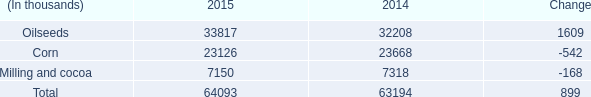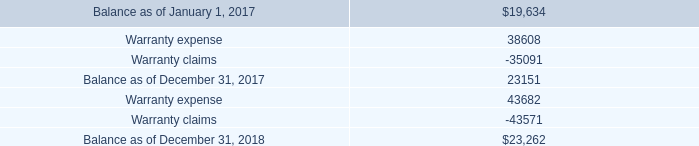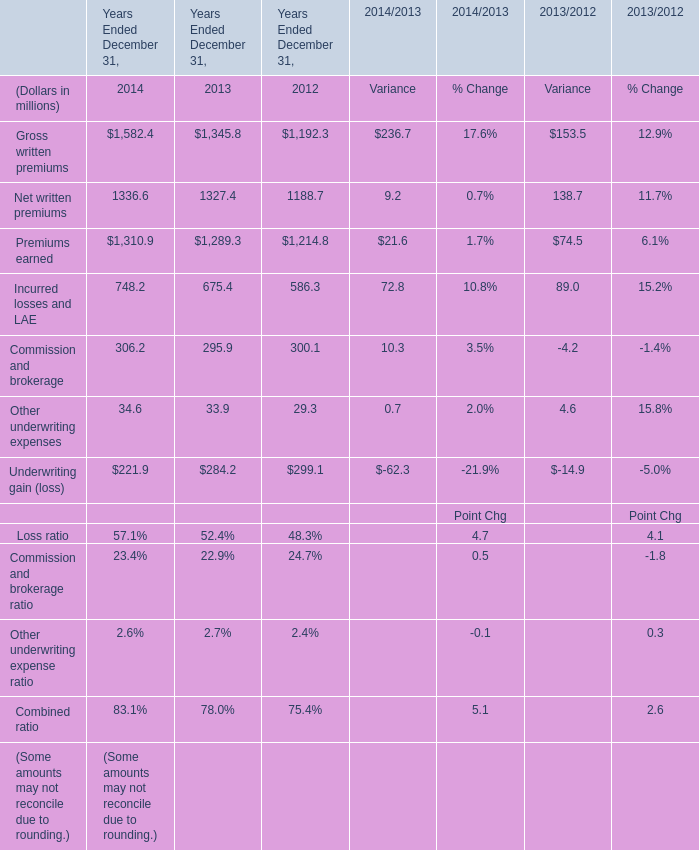What's the sum of Gross written premiums of Years Ended December 31, 2012, and Milling and cocoa of 2014 ? 
Computations: (1192.3 + 7318.0)
Answer: 8510.3. 